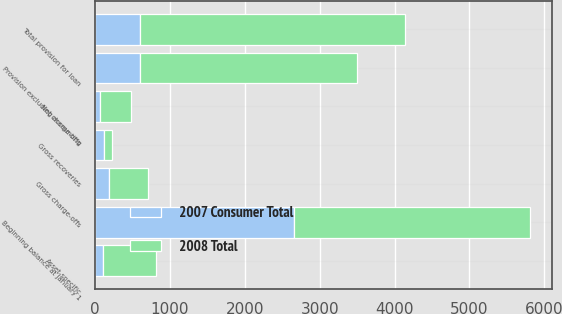<chart> <loc_0><loc_0><loc_500><loc_500><stacked_bar_chart><ecel><fcel>Beginning balance at January 1<fcel>Gross charge-offs<fcel>Gross recoveries<fcel>Net charge-offs<fcel>Provision excluding accounting<fcel>Total provision for loan<fcel>Asset-specific<nl><fcel>2008 Total<fcel>3154<fcel>521<fcel>119<fcel>402<fcel>2895<fcel>3536<fcel>712<nl><fcel>2007 Consumer Total<fcel>2655<fcel>185<fcel>113<fcel>72<fcel>598<fcel>598<fcel>108<nl></chart> 